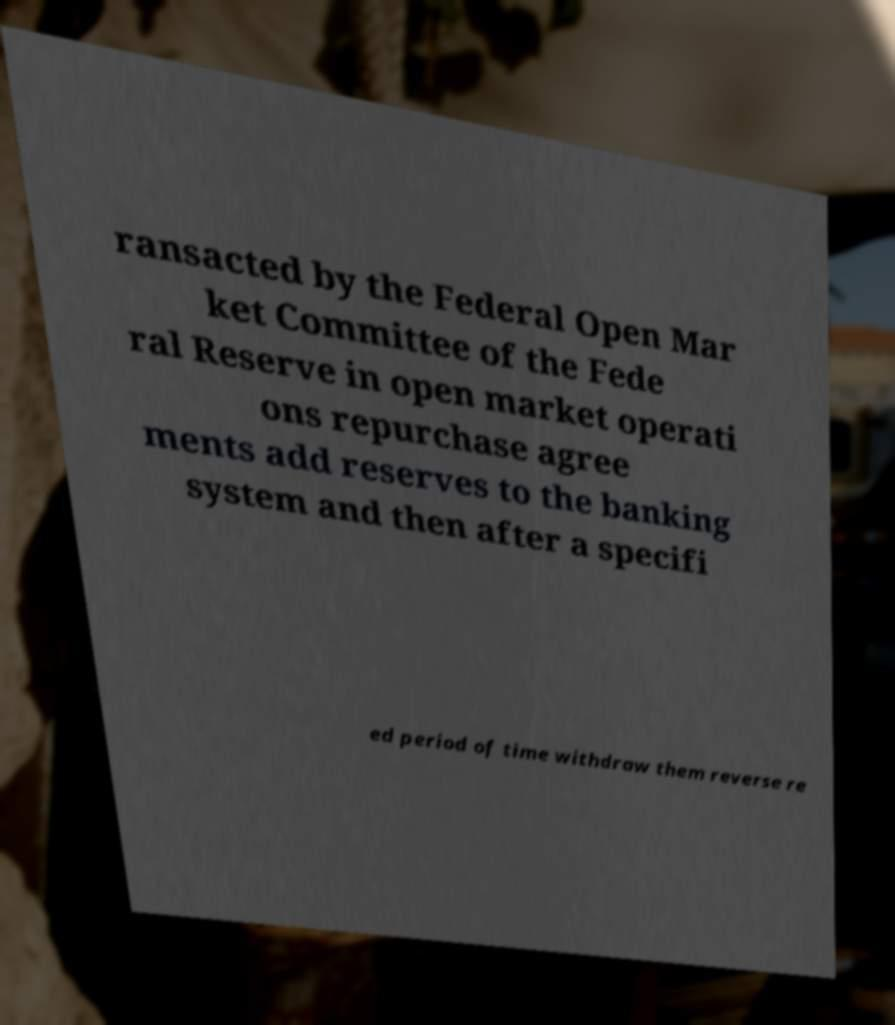Please read and relay the text visible in this image. What does it say? ransacted by the Federal Open Mar ket Committee of the Fede ral Reserve in open market operati ons repurchase agree ments add reserves to the banking system and then after a specifi ed period of time withdraw them reverse re 